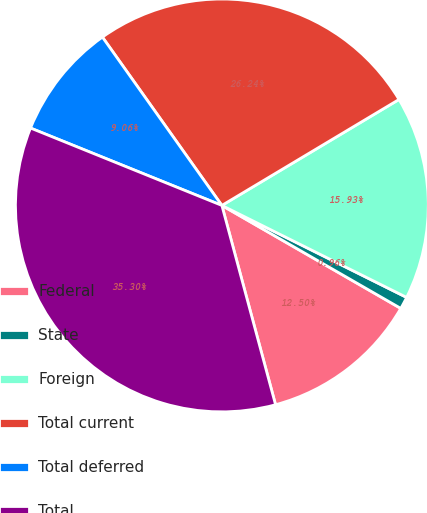<chart> <loc_0><loc_0><loc_500><loc_500><pie_chart><fcel>Federal<fcel>State<fcel>Foreign<fcel>Total current<fcel>Total deferred<fcel>Total<nl><fcel>12.5%<fcel>0.96%<fcel>15.93%<fcel>26.24%<fcel>9.06%<fcel>35.3%<nl></chart> 